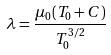<formula> <loc_0><loc_0><loc_500><loc_500>\lambda = \frac { \mu _ { 0 } ( T _ { 0 } + C ) } { T _ { 0 } ^ { 3 / 2 } }</formula> 